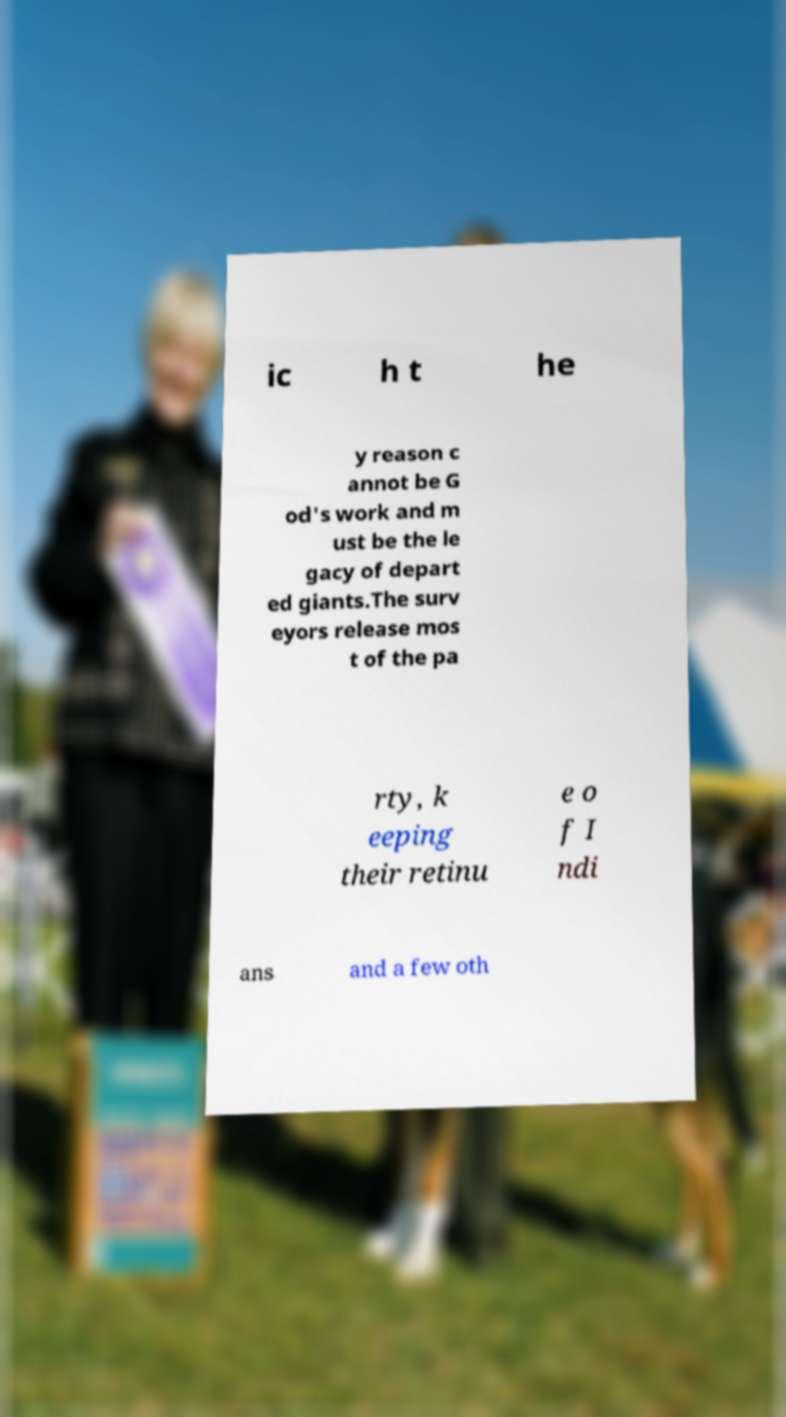There's text embedded in this image that I need extracted. Can you transcribe it verbatim? ic h t he y reason c annot be G od's work and m ust be the le gacy of depart ed giants.The surv eyors release mos t of the pa rty, k eeping their retinu e o f I ndi ans and a few oth 